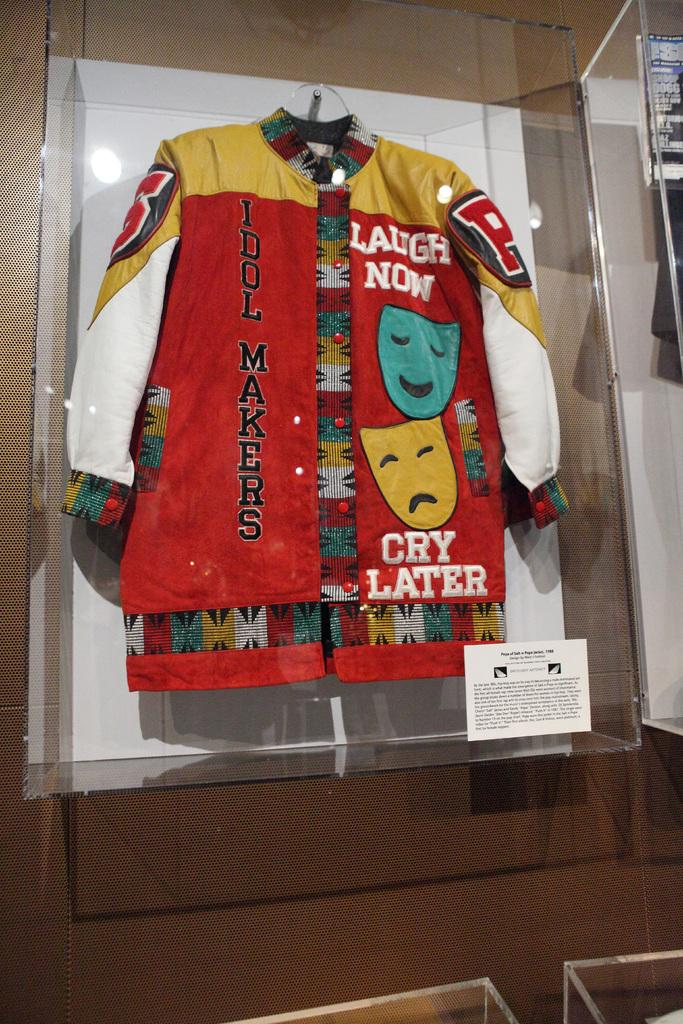<image>
Describe the image concisely. a jacket that has the words cry later on it 